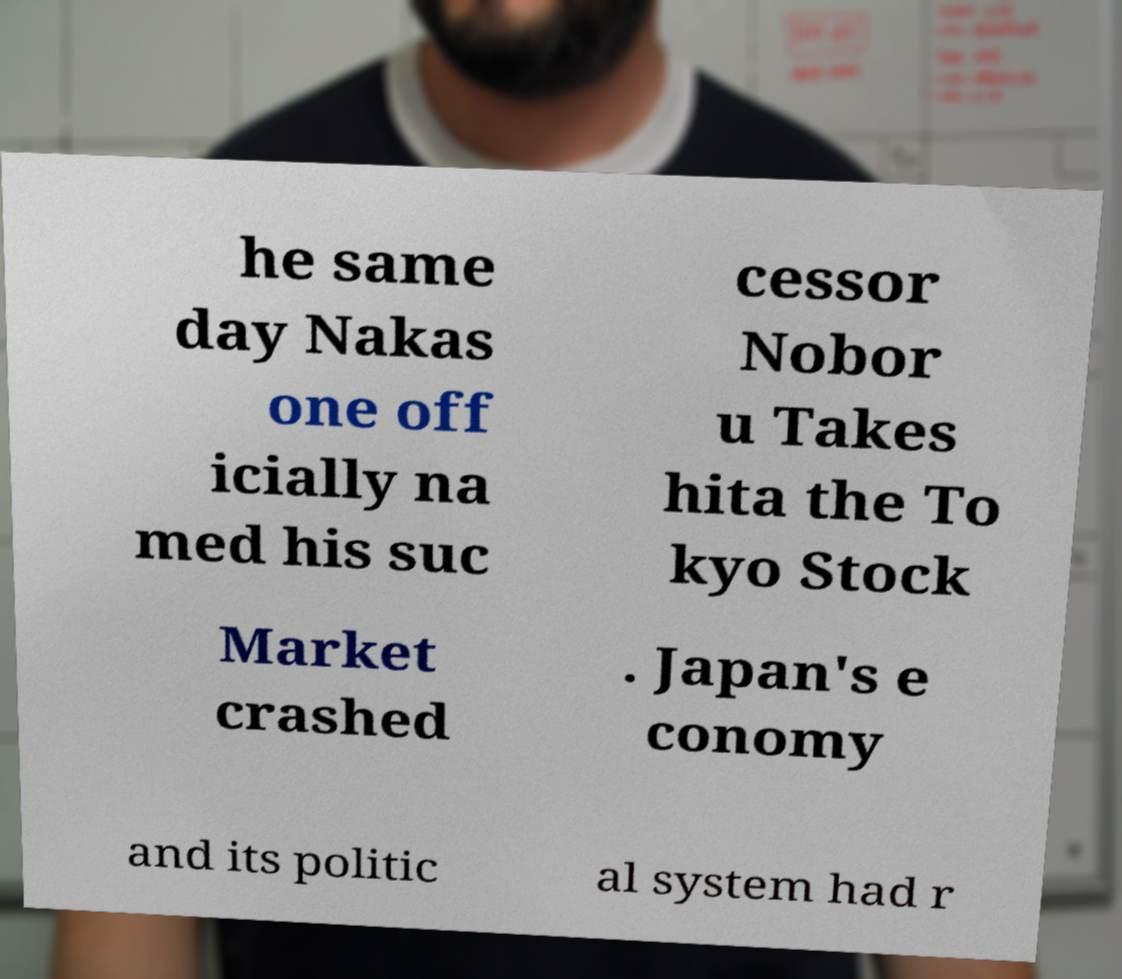Can you read and provide the text displayed in the image?This photo seems to have some interesting text. Can you extract and type it out for me? he same day Nakas one off icially na med his suc cessor Nobor u Takes hita the To kyo Stock Market crashed . Japan's e conomy and its politic al system had r 